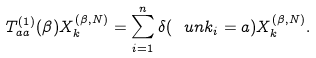Convert formula to latex. <formula><loc_0><loc_0><loc_500><loc_500>T _ { a a } ^ { ( 1 ) } ( \beta ) X _ { k } ^ { ( \beta , N ) } = \sum _ { i = 1 } ^ { n } \delta ( \ u n { k _ { i } } = a ) X _ { k } ^ { ( \beta , N ) } .</formula> 